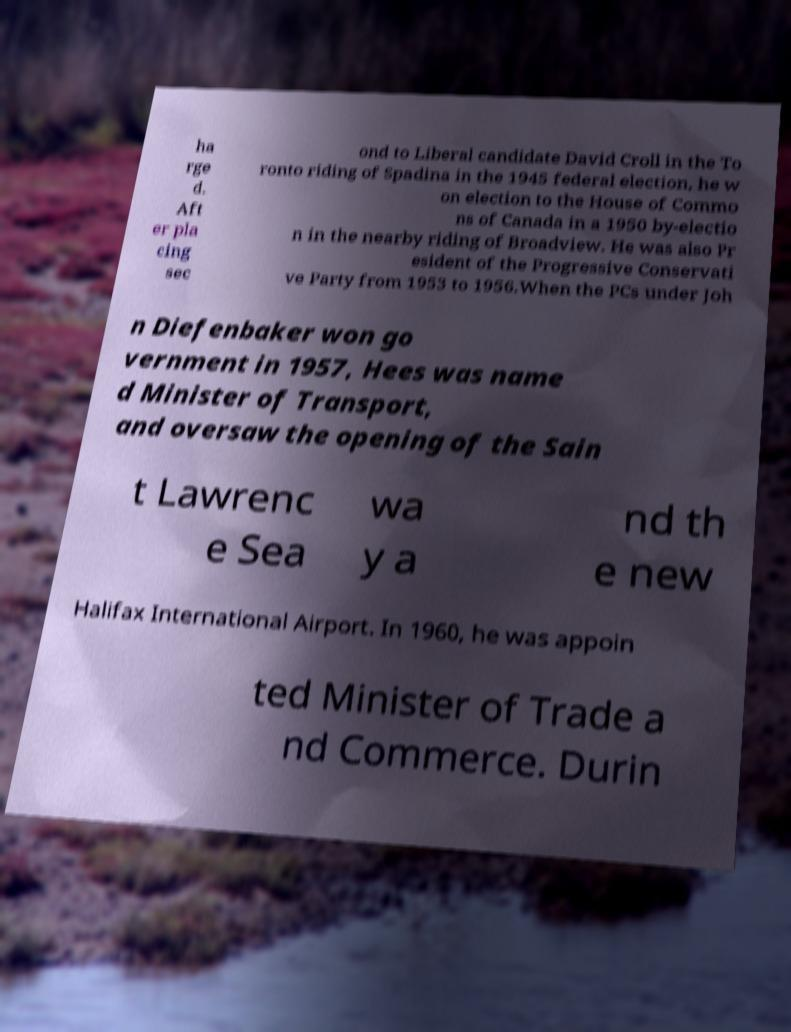What messages or text are displayed in this image? I need them in a readable, typed format. ha rge d. Aft er pla cing sec ond to Liberal candidate David Croll in the To ronto riding of Spadina in the 1945 federal election, he w on election to the House of Commo ns of Canada in a 1950 by-electio n in the nearby riding of Broadview. He was also Pr esident of the Progressive Conservati ve Party from 1953 to 1956.When the PCs under Joh n Diefenbaker won go vernment in 1957, Hees was name d Minister of Transport, and oversaw the opening of the Sain t Lawrenc e Sea wa y a nd th e new Halifax International Airport. In 1960, he was appoin ted Minister of Trade a nd Commerce. Durin 